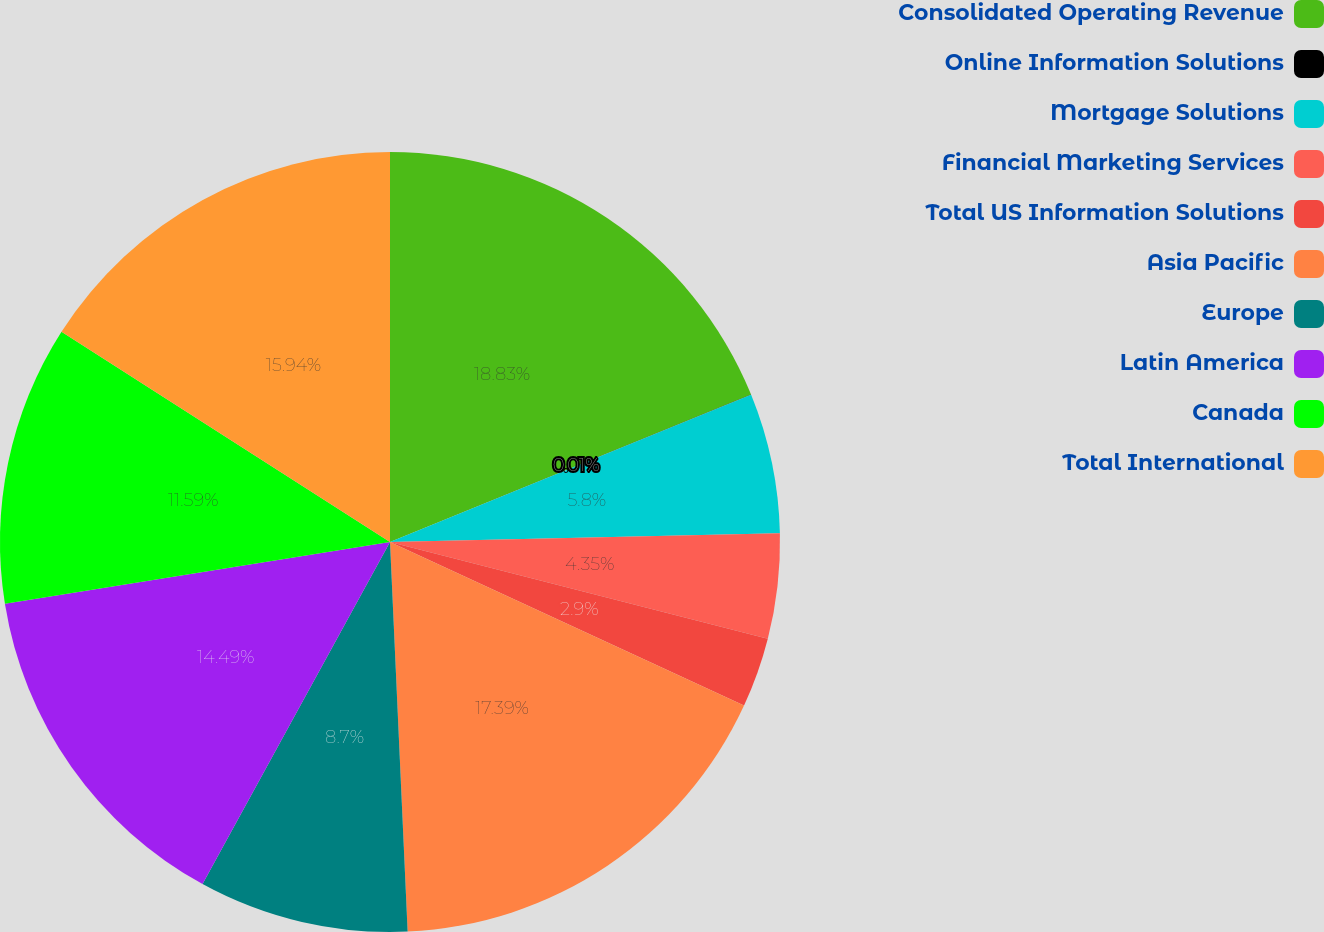<chart> <loc_0><loc_0><loc_500><loc_500><pie_chart><fcel>Consolidated Operating Revenue<fcel>Online Information Solutions<fcel>Mortgage Solutions<fcel>Financial Marketing Services<fcel>Total US Information Solutions<fcel>Asia Pacific<fcel>Europe<fcel>Latin America<fcel>Canada<fcel>Total International<nl><fcel>18.83%<fcel>0.01%<fcel>5.8%<fcel>4.35%<fcel>2.9%<fcel>17.39%<fcel>8.7%<fcel>14.49%<fcel>11.59%<fcel>15.94%<nl></chart> 